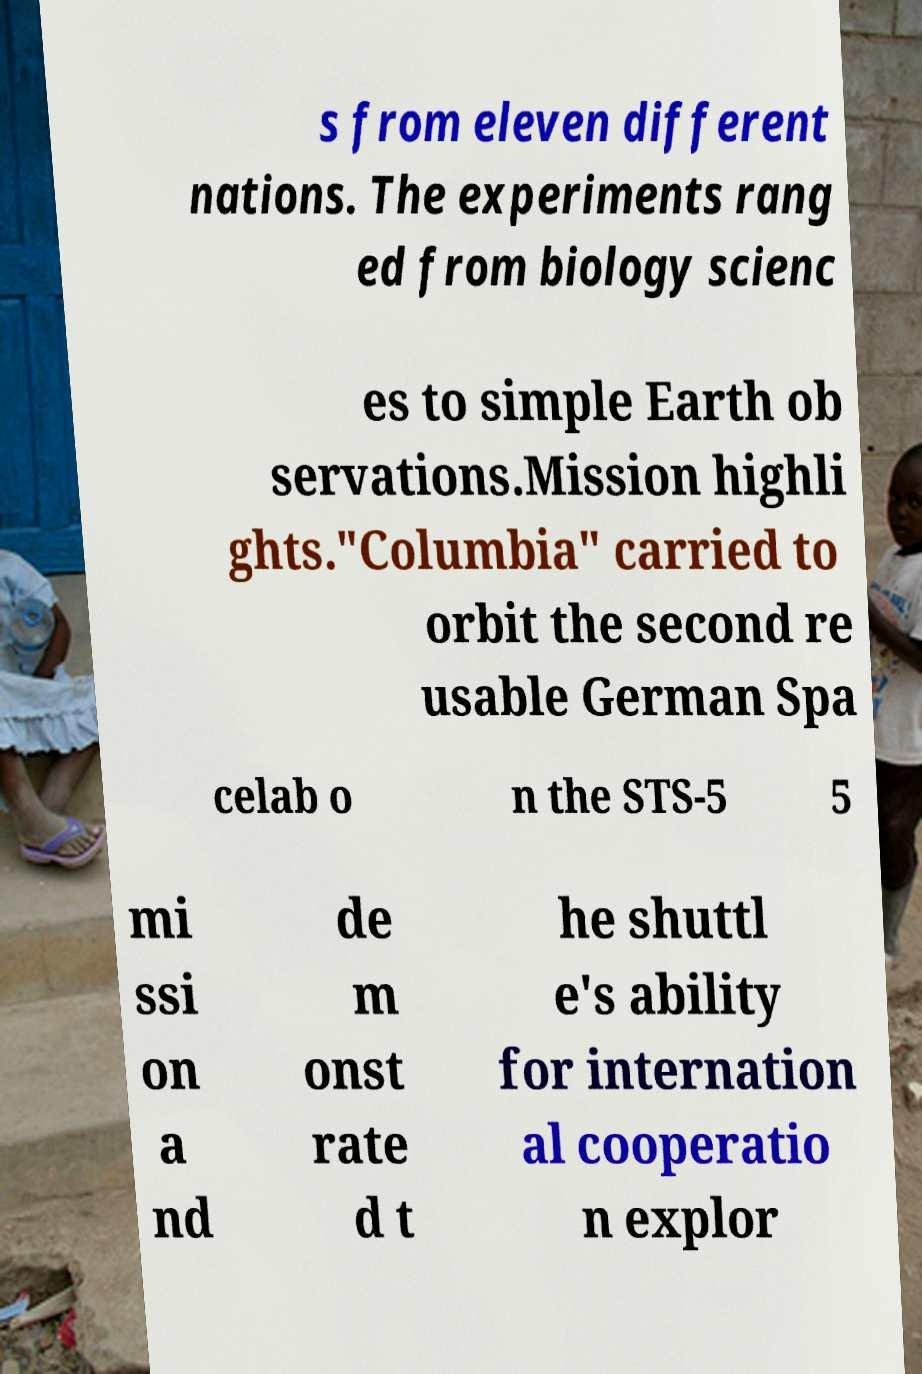Please read and relay the text visible in this image. What does it say? s from eleven different nations. The experiments rang ed from biology scienc es to simple Earth ob servations.Mission highli ghts."Columbia" carried to orbit the second re usable German Spa celab o n the STS-5 5 mi ssi on a nd de m onst rate d t he shuttl e's ability for internation al cooperatio n explor 